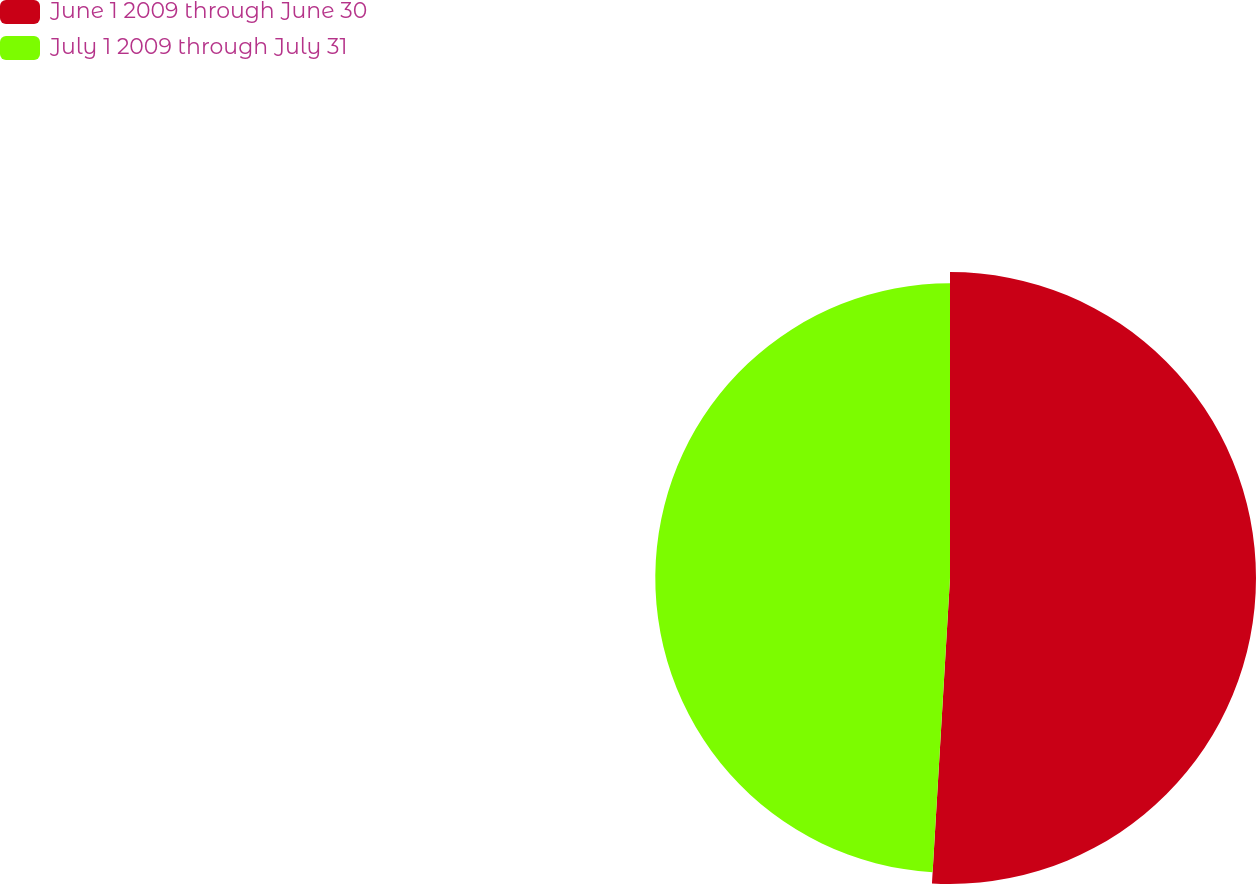Convert chart. <chart><loc_0><loc_0><loc_500><loc_500><pie_chart><fcel>June 1 2009 through June 30<fcel>July 1 2009 through July 31<nl><fcel>50.94%<fcel>49.06%<nl></chart> 